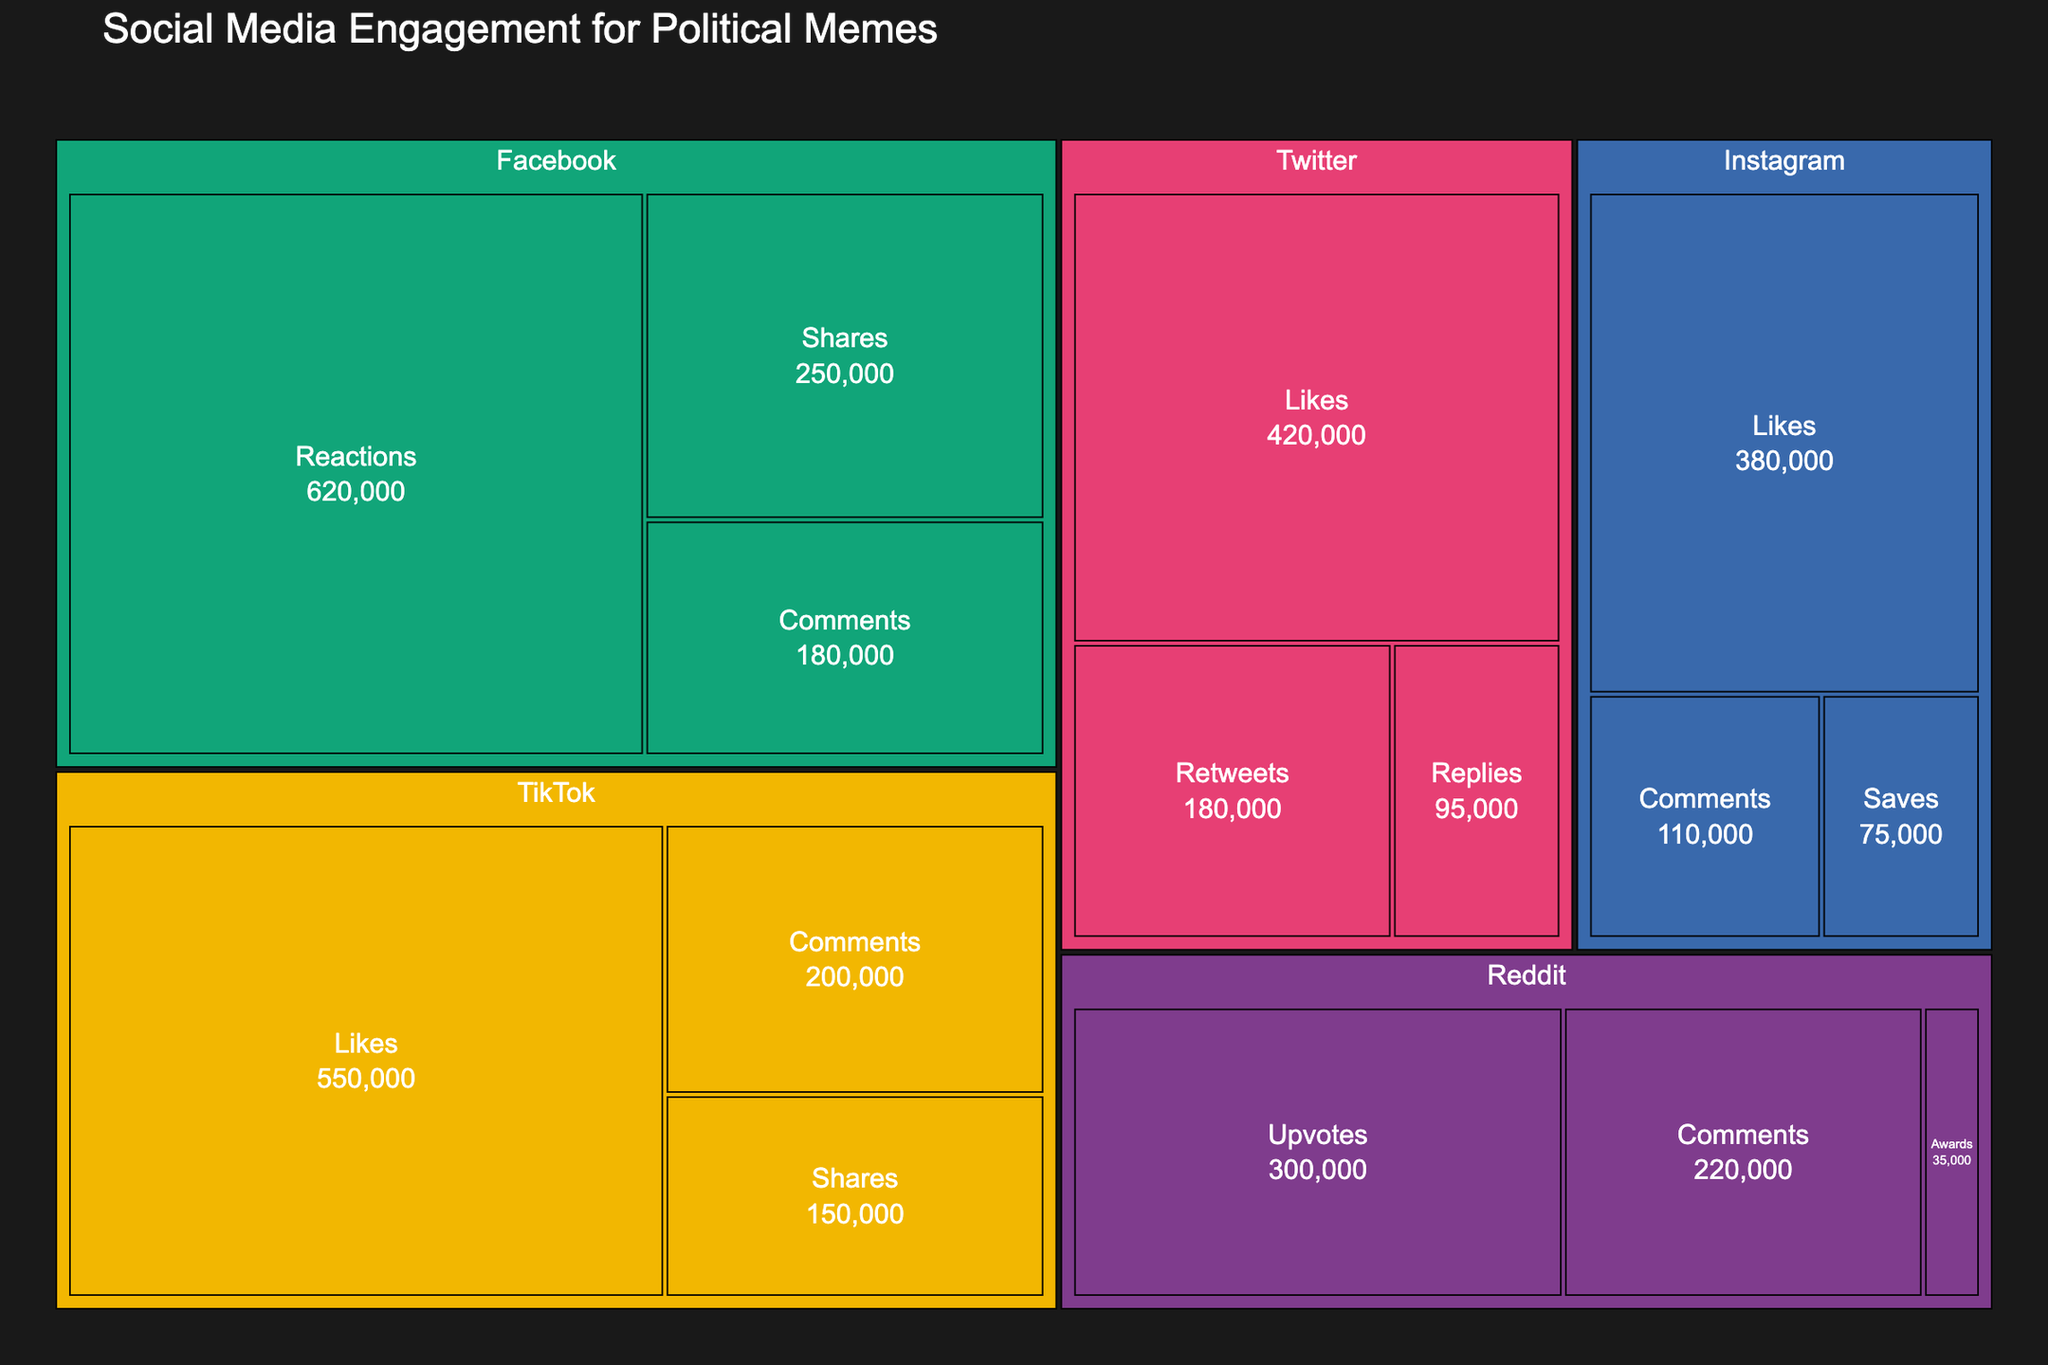How many engagement metrics are presented for Facebook? The Treemap shows multiple social media platforms with various engagement metrics within each platform. By locating Facebook and counting the distinct engagement metrics, we see that Facebook has engagement metrics of Shares, Comments, and Reactions.
Answer: 3 Which platform has the highest engagement value for a single metric? To determine the highest engagement value, analyze each platform's subcategories and identify the largest value. By doing this, it is evident that TikTok's Likes have the highest value, which is 550,000.
Answer: TikTok What is the total number of Likes across all platforms? To find the total number of Likes, we sum up the values from all platforms: Twitter (420,000) + Instagram (380,000) + TikTok (550,000). This totals to 1,350,000.
Answer: 1,350,000 Which platform has the lowest engagement value, and what is that value? By scanning through all the engagement metrics in the Treemap, we see that Reddit's Awards have the lowest value, which is 35,000.
Answer: Reddit, 35,000 Among the different platforms, which one has the highest combined value for Comments? To find this, we sum the values for Comments on each platform and compare. Facebook (180,000) + Instagram (110,000) + Reddit (220,000) + TikTok (200,000). Reddit has highest total with 220,000.
Answer: Reddit What is the combined engagement value for Instagram? Adding all the engagement metrics for Instagram: Likes (380,000) + Comments (110,000) + Saves (75,000) gives a total value of 565,000.
Answer: 565,000 How many more Comments does Reddit have compared to Twitter Replies? The number of Comments for Reddit is 220,000, and the number of Replies for Twitter is 95,000. Subtracting these values gives 220,000 - 95,000 = 125,000.
Answer: 125,000 Which engagement metric is the second most popular on Facebook? Analyzing the values specific to Facebook metrics, Shares are 250,000, Comments are 180,000, and Reactions are 620,000. The second highest value here is 250,000 (Shares).
Answer: Shares What is the average number of engagements for TikTok’s metrics? Summing the values for TikTok's metrics: Likes (550,000) + Comments (200,000) + Shares (150,000) gives a total of 900,000. Dividing this by the number of metrics (3) results in an average of 300,000.
Answer: 300,000 